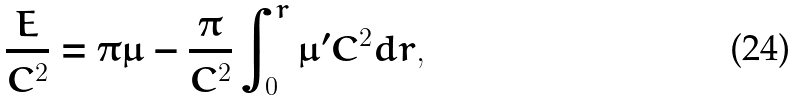Convert formula to latex. <formula><loc_0><loc_0><loc_500><loc_500>\frac { E } { C ^ { 2 } } = \pi \mu - \frac { \pi } { C ^ { 2 } } \int ^ { r } _ { 0 } { \mu ^ { \prime } } { C ^ { 2 } } d r ,</formula> 